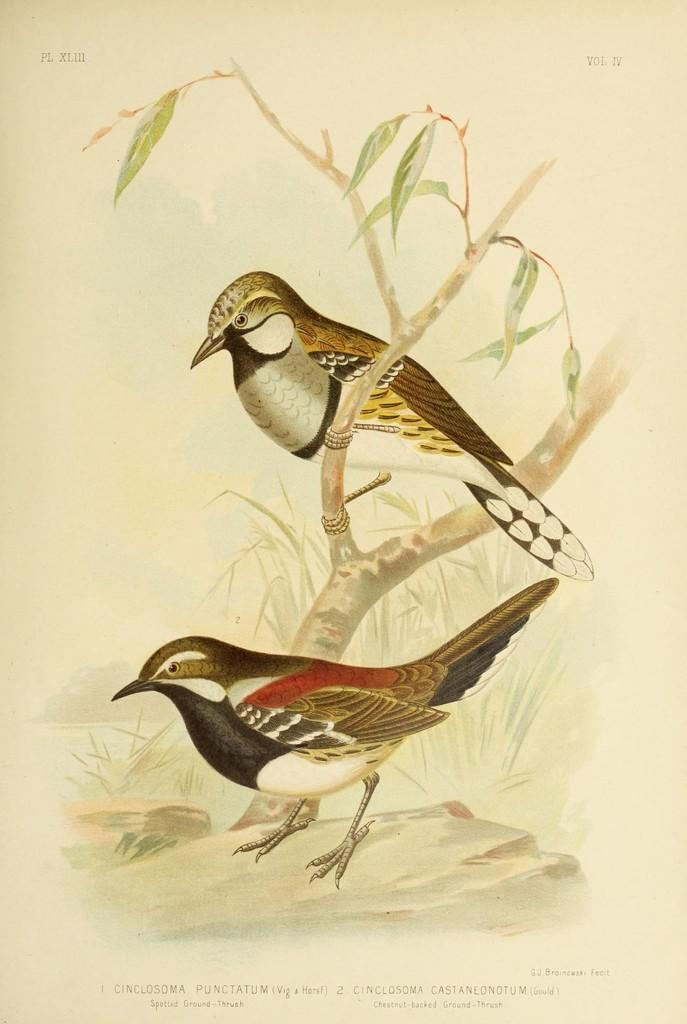What is on the paper in the image? There is writing and a painting of birds on the paper. Can you describe the painting on the paper? The painting on the paper features birds, with one bird sitting on a branch of a tree. What is the bird in the painting doing? The bird is sitting on a branch of a tree. What type of jam is being spread on the stocking in the image? There is no jam or stocking present in the image; it features writing and a painting of birds on a paper. How many cherries are hanging from the tree in the painting? There are no cherries depicted in the painting; it features birds, with one bird sitting on a branch of a tree. 